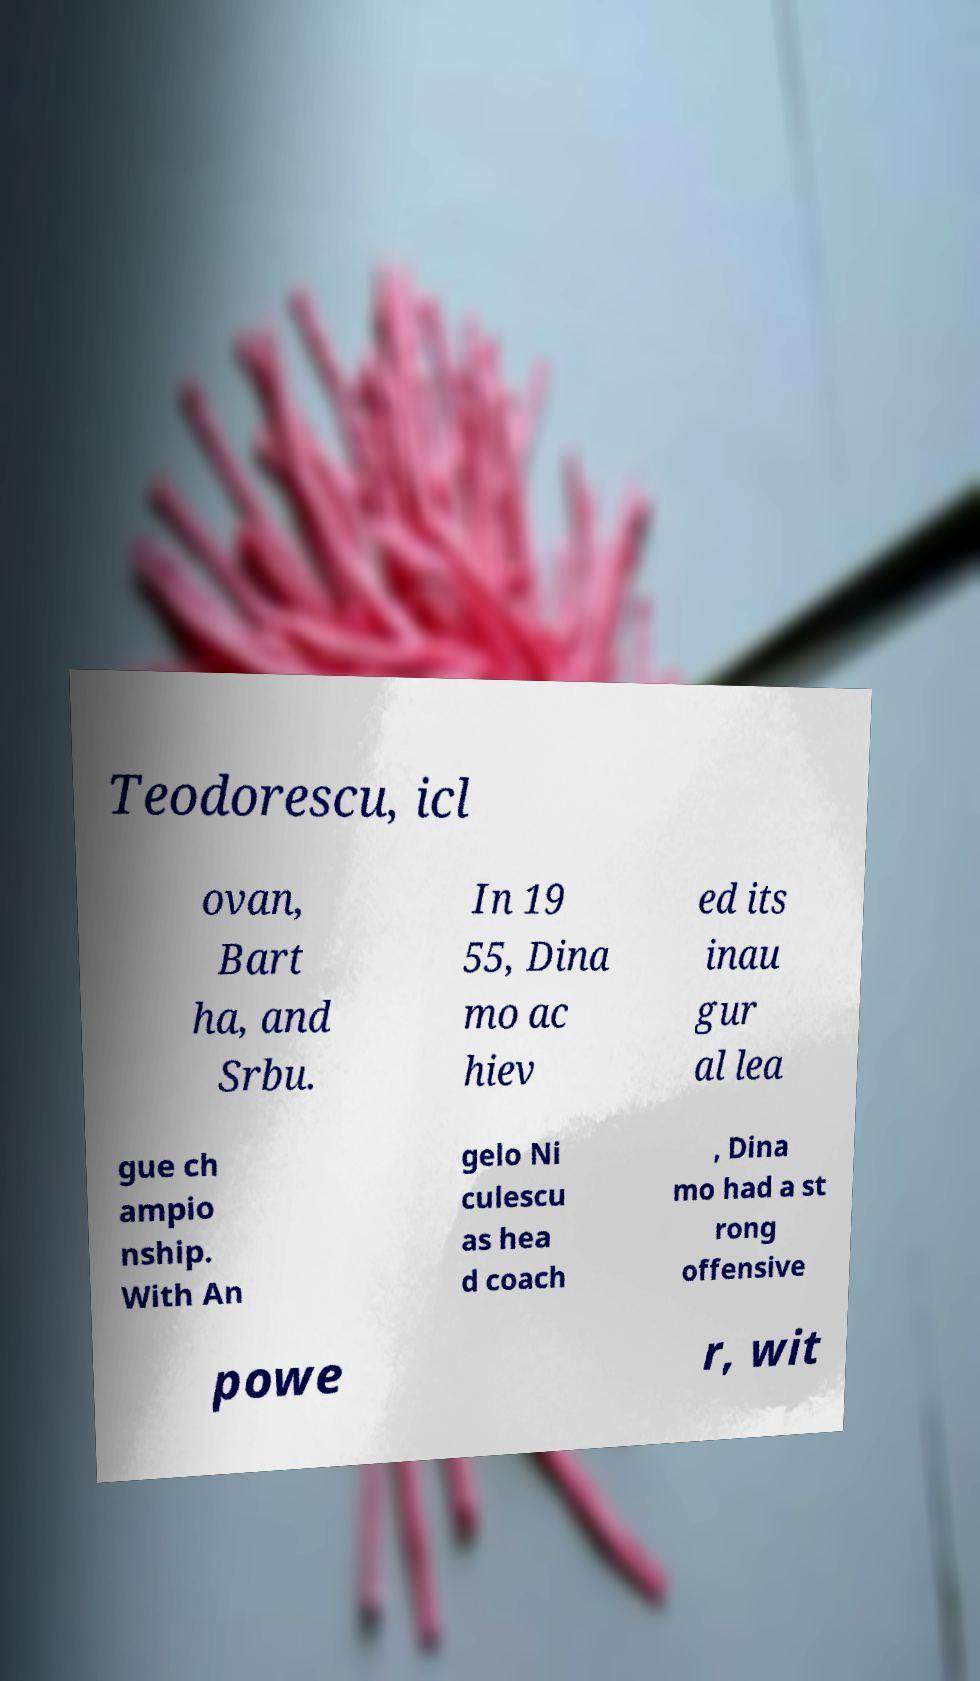There's text embedded in this image that I need extracted. Can you transcribe it verbatim? Teodorescu, icl ovan, Bart ha, and Srbu. In 19 55, Dina mo ac hiev ed its inau gur al lea gue ch ampio nship. With An gelo Ni culescu as hea d coach , Dina mo had a st rong offensive powe r, wit 